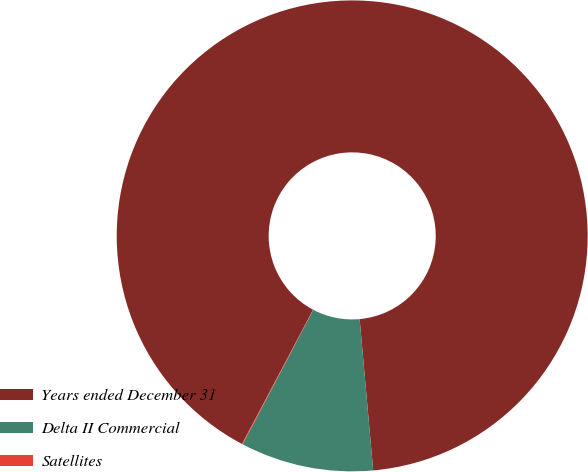Convert chart to OTSL. <chart><loc_0><loc_0><loc_500><loc_500><pie_chart><fcel>Years ended December 31<fcel>Delta II Commercial<fcel>Satellites<nl><fcel>90.83%<fcel>9.12%<fcel>0.05%<nl></chart> 